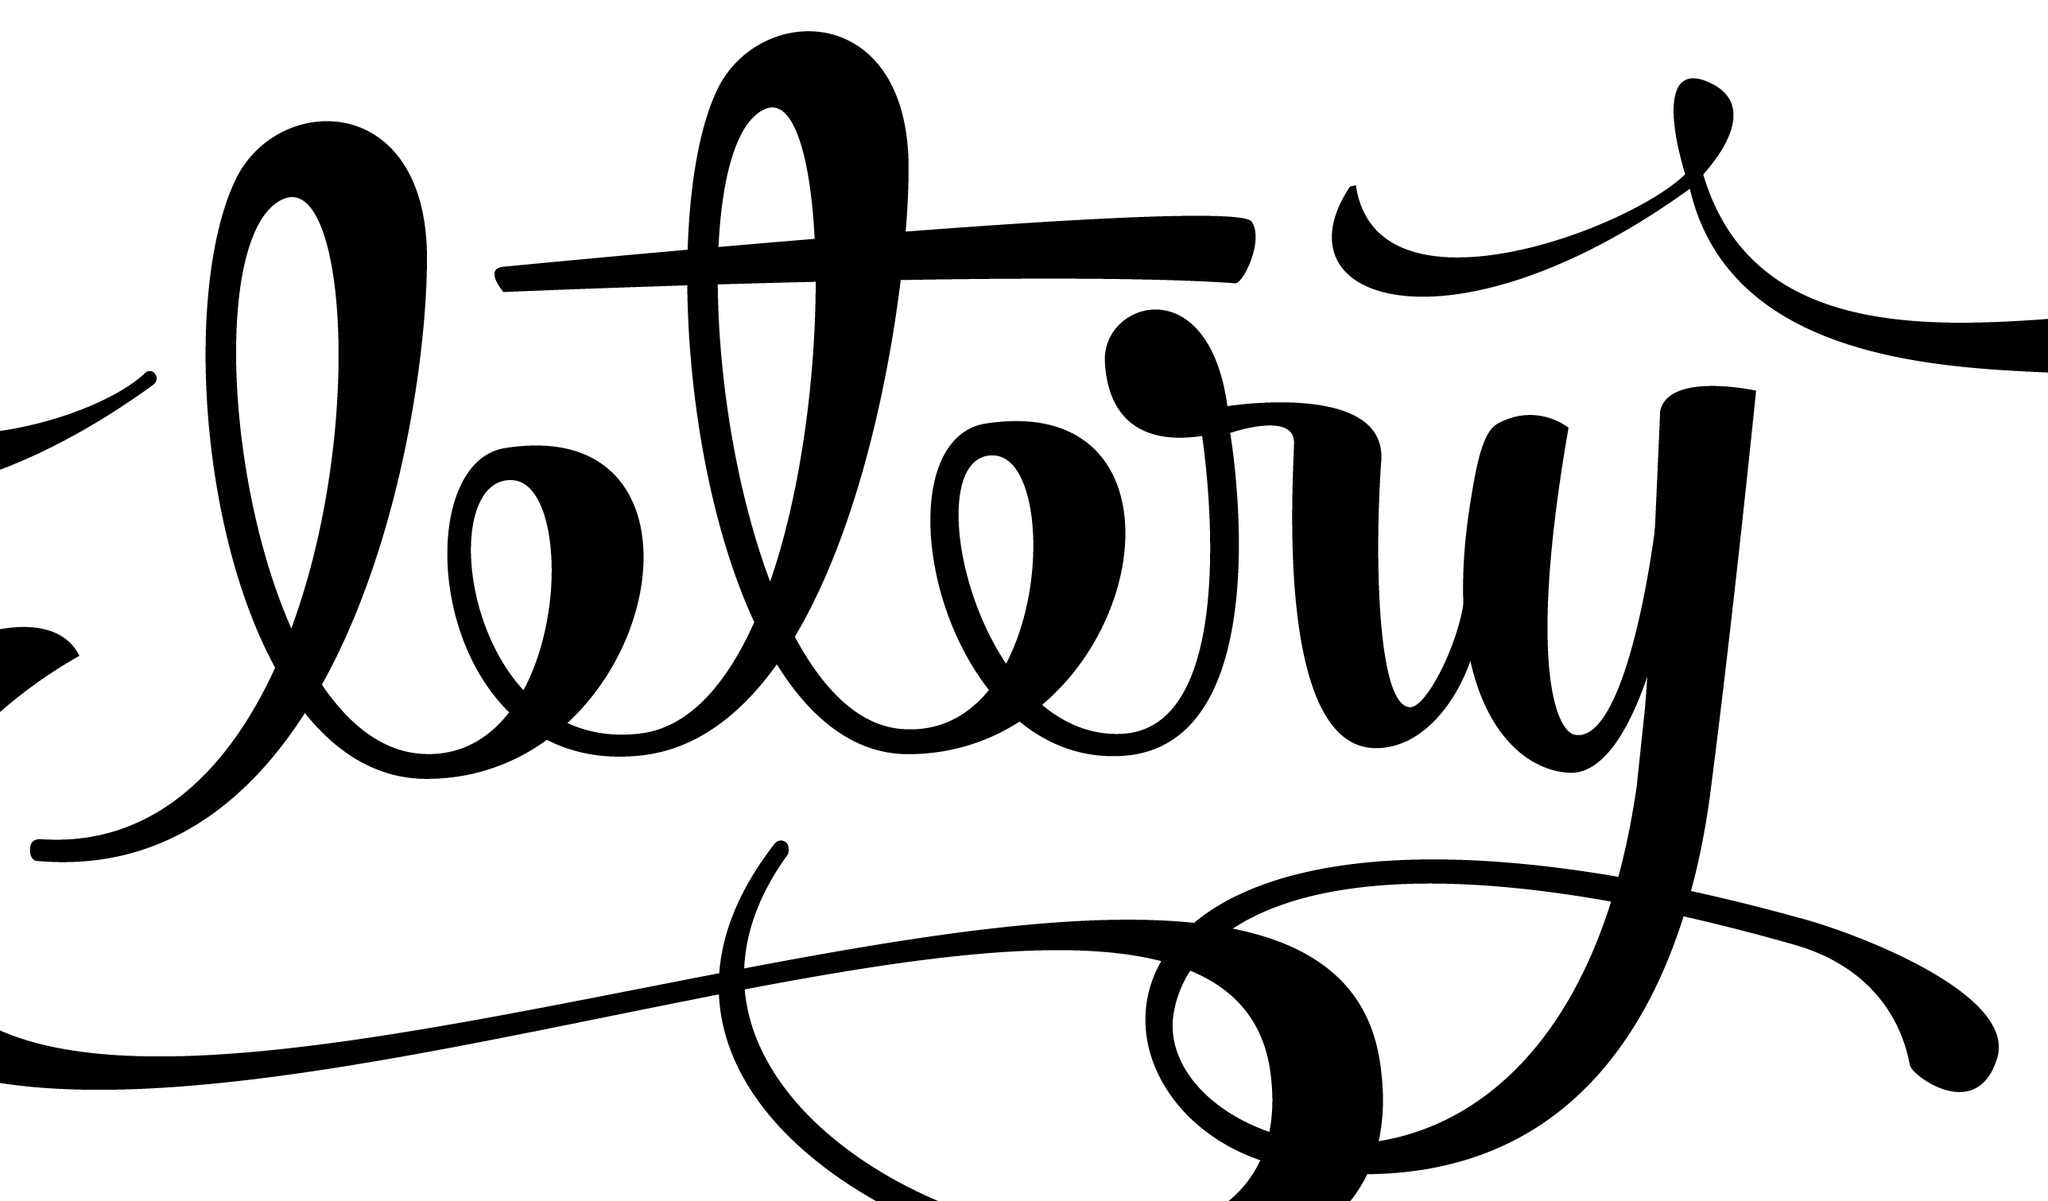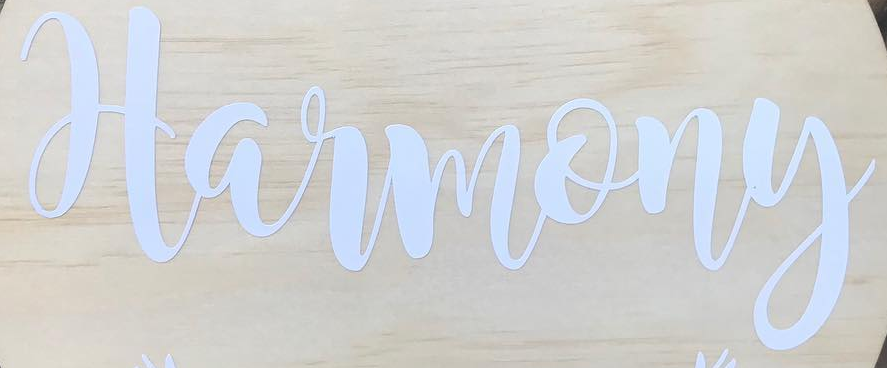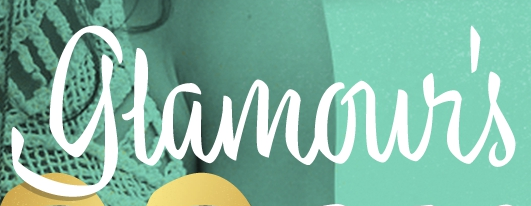What text appears in these images from left to right, separated by a semicolon? ltry; Harmony; glamour's 